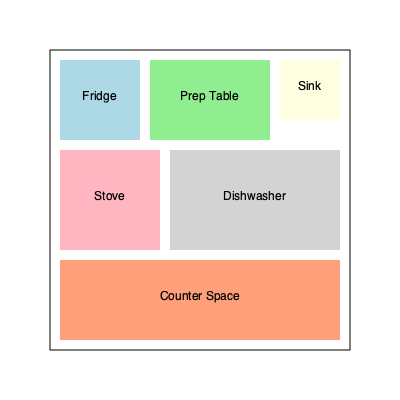In a compact kitchen layout, what is the most efficient arrangement of equipment to maximize workflow and minimize cross-contamination? Consider the placement of the fridge, prep table, sink, stove, dishwasher, and counter space. 1. Analyze the kitchen layout:
   - The kitchen is represented by a 300x300 unit square.
   - Equipment includes: fridge, prep table, sink, stove, dishwasher, and counter space.

2. Efficient workflow principles:
   - Create a work triangle between the fridge, sink, and stove.
   - Place the prep table near the fridge for easy access to ingredients.
   - Position the sink between the prep area and cooking area.

3. Cross-contamination prevention:
   - Separate raw food preparation from cooked food areas.
   - Place the dishwasher near the sink for easy transfer of dirty dishes.

4. Optimal arrangement (as shown in the diagram):
   - Top left: Fridge (80x80 units)
   - Top center: Prep table (120x80 units)
   - Top right: Sink (60x60 units)
   - Middle left: Stove (100x100 units)
   - Middle right: Dishwasher (170x100 units)
   - Bottom: Counter space (280x80 units)

5. Workflow efficiency:
   - The fridge, prep table, and sink are aligned for smooth food preparation.
   - The stove is adjacent to the prep area for easy transfer of prepared ingredients.
   - The sink is centrally located, accessible from both prep and cooking areas.

6. Cross-contamination prevention:
   - The prep table is separated from the cooking area by the sink.
   - The dishwasher is placed next to the sink for efficient cleaning.
   - The counter space provides additional area for cooling cooked foods.

This arrangement optimizes the kitchen workflow while minimizing the risk of cross-contamination, making the most of the limited space available.
Answer: Fridge-Prep-Sink (top), Stove-Dishwasher (middle), Counter (bottom) 